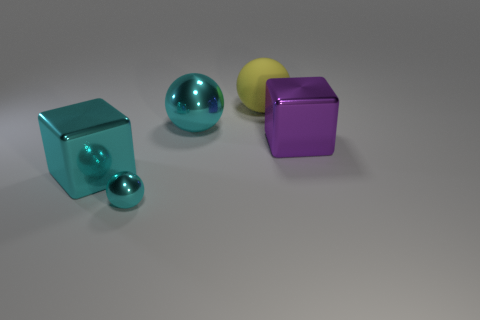Add 4 cyan objects. How many objects exist? 9 Subtract all blocks. How many objects are left? 3 Add 5 large yellow rubber objects. How many large yellow rubber objects exist? 6 Subtract 0 gray balls. How many objects are left? 5 Subtract all green matte cubes. Subtract all yellow spheres. How many objects are left? 4 Add 5 cubes. How many cubes are left? 7 